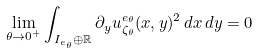Convert formula to latex. <formula><loc_0><loc_0><loc_500><loc_500>\lim _ { \theta \to 0 ^ { + } } \int _ { I _ { e _ { \theta } } \oplus \mathbb { R } } \partial _ { y } u _ { \zeta _ { \theta } } ^ { e _ { \theta } } ( x , y ) ^ { 2 } \, d x \, d y = 0</formula> 